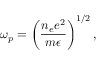Convert formula to latex. <formula><loc_0><loc_0><loc_500><loc_500>\omega _ { p } = \left ( \frac { n _ { e } e ^ { 2 } } { m \epsilon } \right ) ^ { 1 / 2 } ,</formula> 